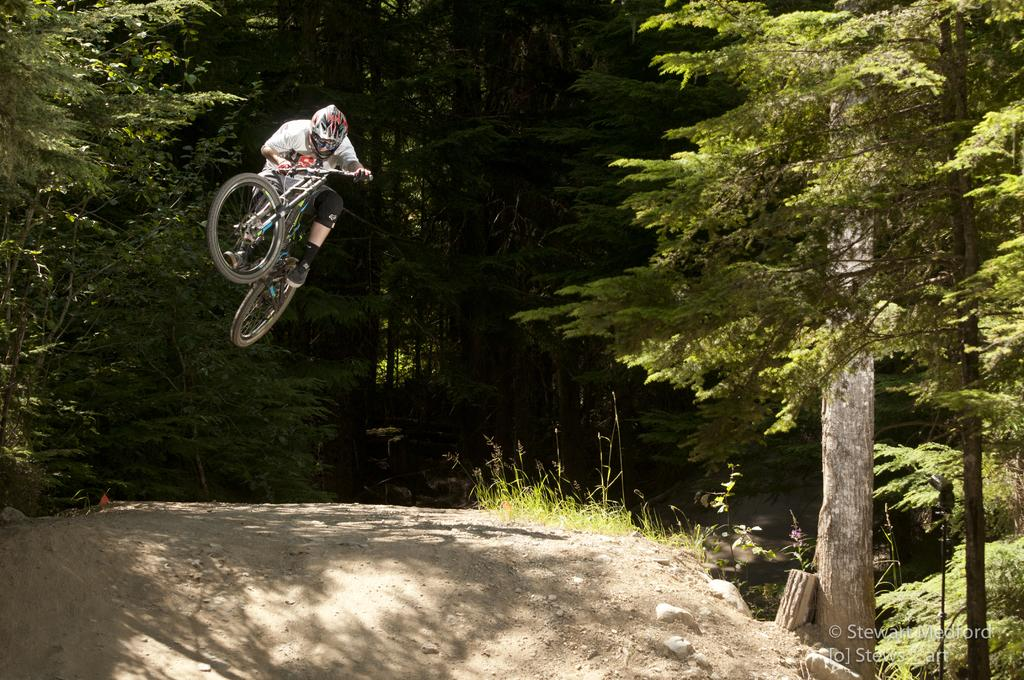What is the main activity being performed by the person in the image? There is a person cycling in the image. What can be seen in the background of the image? There are trees and plants visible in the background of the image. Is there any text present in the image? Yes, there is some text in the bottom right corner of the image. Where is the shelf located in the image? There is no shelf present in the image. What type of quiver can be seen on the person cycling? There is no quiver present in the image; the person is cycling. 